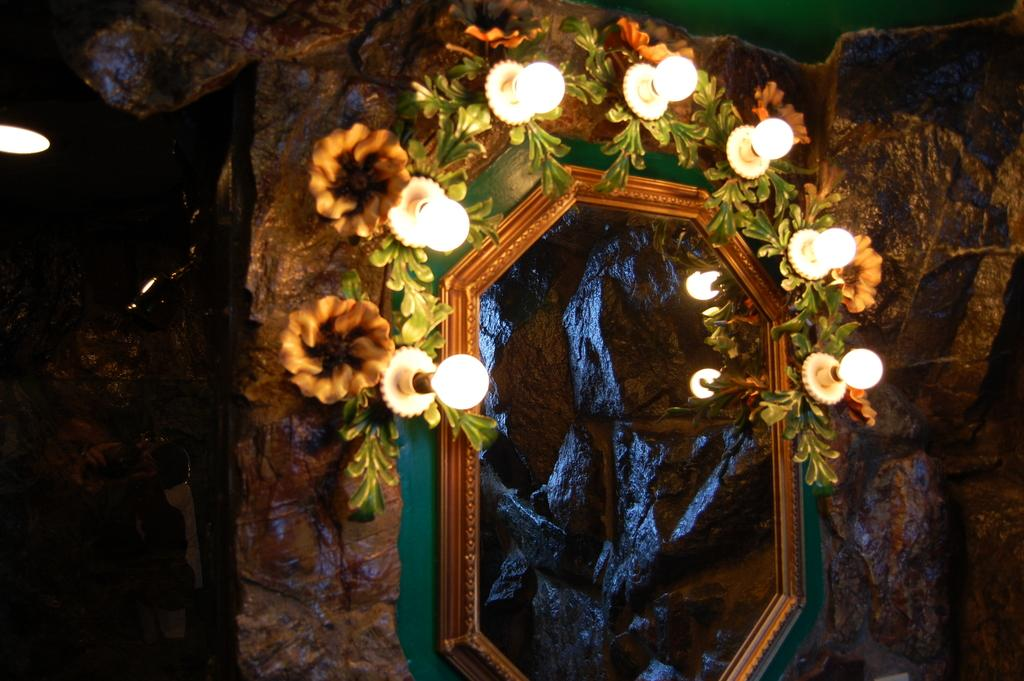What object in the image reflects light? The mirror in the image reflects lights. Can you describe the lights visible in the image? Yes, there are lights visible in the image. What type of decorative elements can be seen in the image? There are decorative flowers in the image. What other natural elements are present in the image? There are leaves in the image. What type of fowl can be seen walking around in the image? There is no fowl present in the image. Can you point out the turkey in the image? There is no turkey present in the image. 